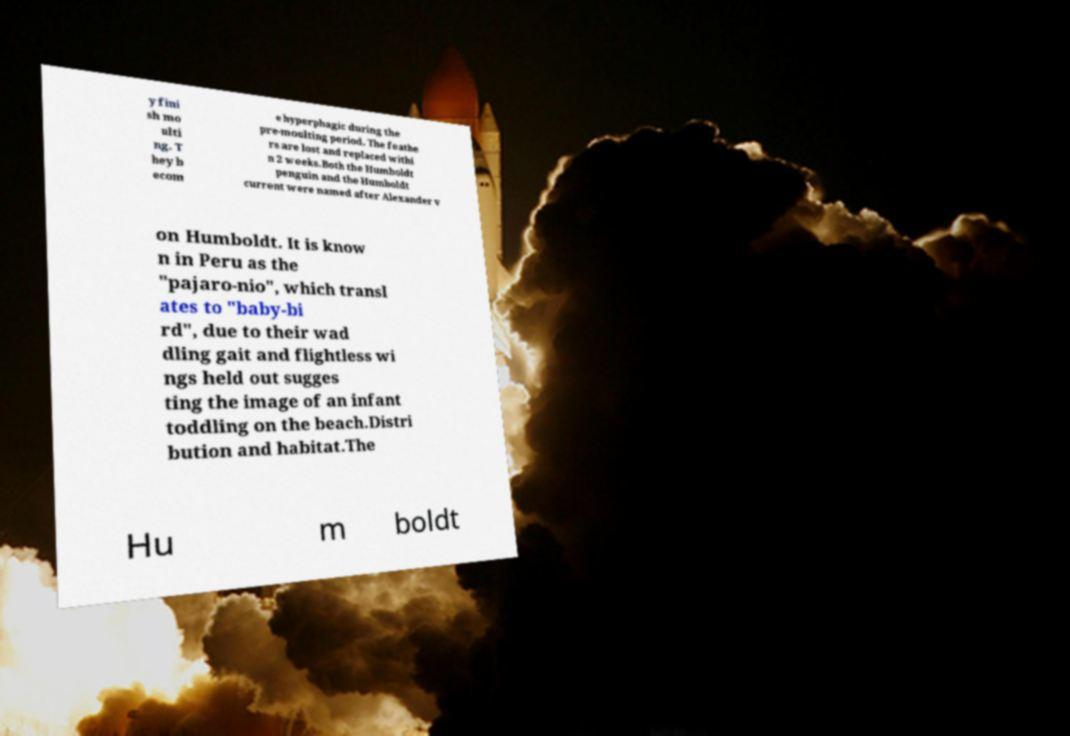What messages or text are displayed in this image? I need them in a readable, typed format. y fini sh mo ulti ng. T hey b ecom e hyperphagic during the pre-moulting period. The feathe rs are lost and replaced withi n 2 weeks.Both the Humboldt penguin and the Humboldt current were named after Alexander v on Humboldt. It is know n in Peru as the "pajaro-nio", which transl ates to "baby-bi rd", due to their wad dling gait and flightless wi ngs held out sugges ting the image of an infant toddling on the beach.Distri bution and habitat.The Hu m boldt 